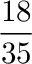Convert formula to latex. <formula><loc_0><loc_0><loc_500><loc_500>\frac { 1 8 } { 3 5 }</formula> 